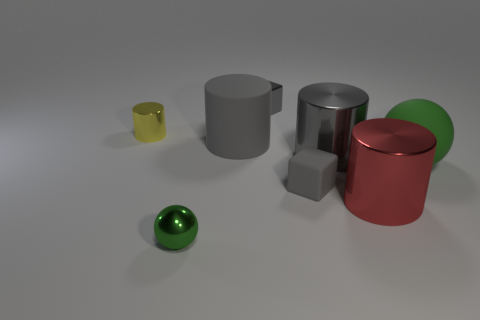Add 1 tiny gray matte cubes. How many objects exist? 9 Subtract all cubes. How many objects are left? 6 Subtract all brown balls. Subtract all green metal things. How many objects are left? 7 Add 7 yellow shiny cylinders. How many yellow shiny cylinders are left? 8 Add 2 green rubber spheres. How many green rubber spheres exist? 3 Subtract 0 purple spheres. How many objects are left? 8 